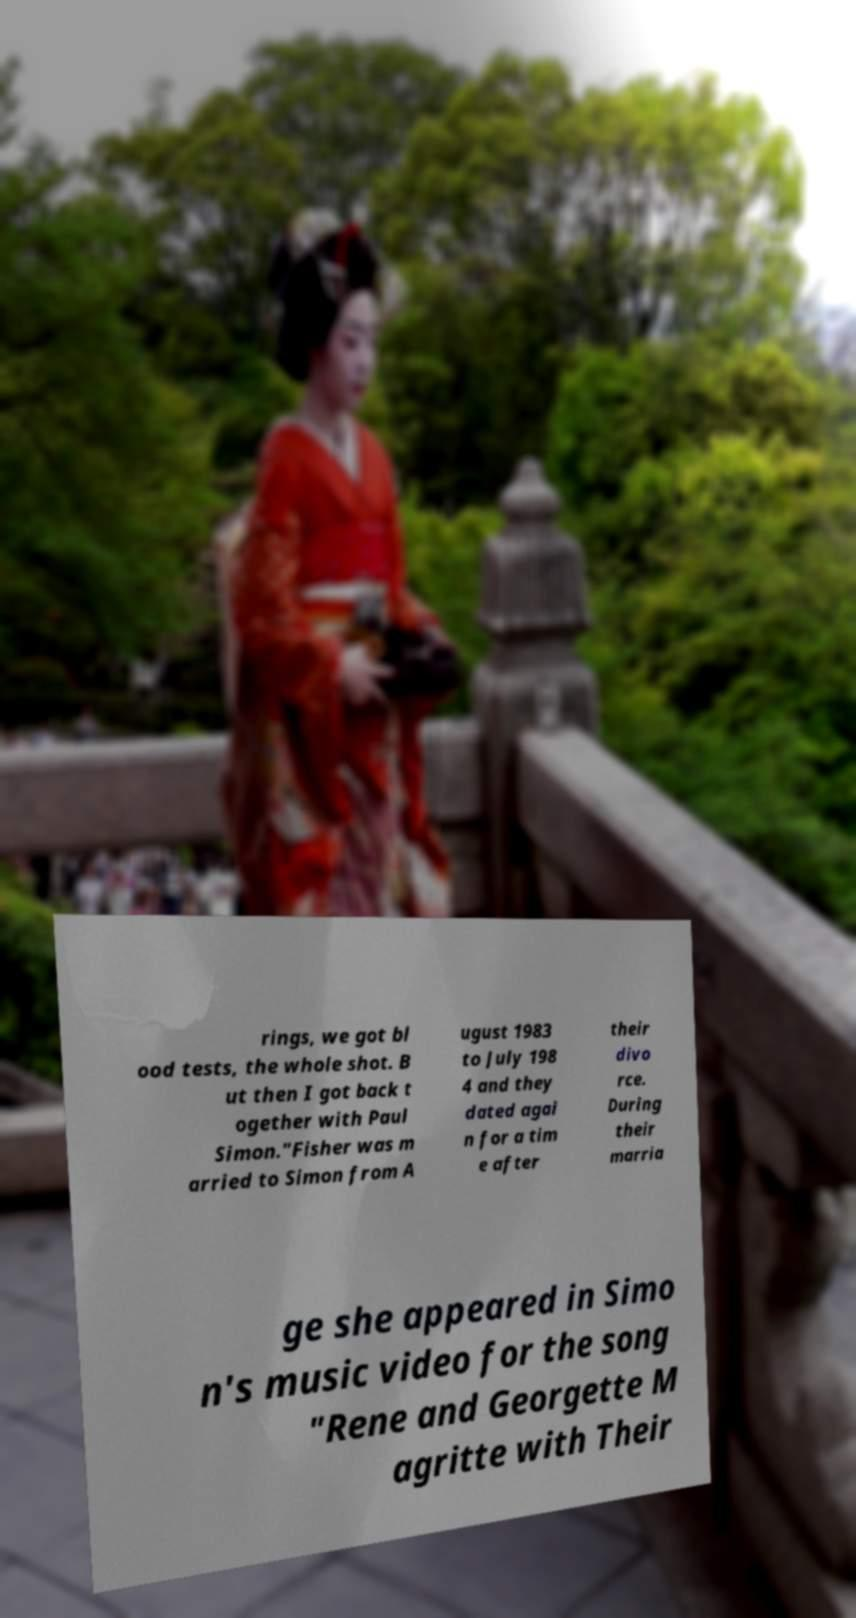There's text embedded in this image that I need extracted. Can you transcribe it verbatim? rings, we got bl ood tests, the whole shot. B ut then I got back t ogether with Paul Simon."Fisher was m arried to Simon from A ugust 1983 to July 198 4 and they dated agai n for a tim e after their divo rce. During their marria ge she appeared in Simo n's music video for the song "Rene and Georgette M agritte with Their 